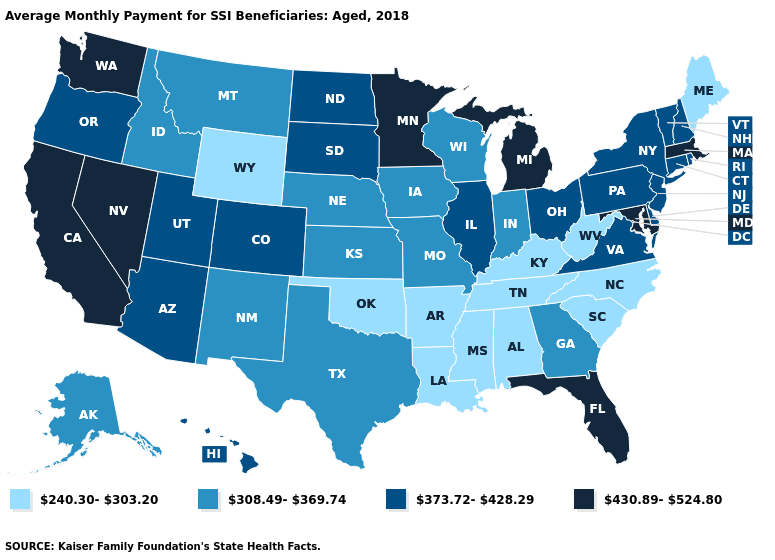Among the states that border Indiana , does Kentucky have the lowest value?
Short answer required. Yes. Name the states that have a value in the range 373.72-428.29?
Quick response, please. Arizona, Colorado, Connecticut, Delaware, Hawaii, Illinois, New Hampshire, New Jersey, New York, North Dakota, Ohio, Oregon, Pennsylvania, Rhode Island, South Dakota, Utah, Vermont, Virginia. Does Florida have the highest value in the South?
Concise answer only. Yes. Which states have the highest value in the USA?
Be succinct. California, Florida, Maryland, Massachusetts, Michigan, Minnesota, Nevada, Washington. What is the highest value in the South ?
Give a very brief answer. 430.89-524.80. Does Missouri have the same value as Delaware?
Concise answer only. No. Is the legend a continuous bar?
Keep it brief. No. What is the value of Pennsylvania?
Quick response, please. 373.72-428.29. What is the value of Louisiana?
Quick response, please. 240.30-303.20. What is the value of Colorado?
Answer briefly. 373.72-428.29. Which states have the lowest value in the Northeast?
Concise answer only. Maine. Which states hav the highest value in the MidWest?
Quick response, please. Michigan, Minnesota. Name the states that have a value in the range 373.72-428.29?
Short answer required. Arizona, Colorado, Connecticut, Delaware, Hawaii, Illinois, New Hampshire, New Jersey, New York, North Dakota, Ohio, Oregon, Pennsylvania, Rhode Island, South Dakota, Utah, Vermont, Virginia. What is the highest value in the MidWest ?
Answer briefly. 430.89-524.80. Which states have the lowest value in the USA?
Quick response, please. Alabama, Arkansas, Kentucky, Louisiana, Maine, Mississippi, North Carolina, Oklahoma, South Carolina, Tennessee, West Virginia, Wyoming. 